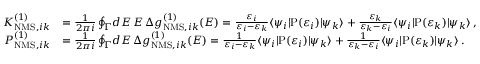Convert formula to latex. <formula><loc_0><loc_0><loc_500><loc_500>\begin{array} { r l } { K _ { N M S , i k } ^ { ( 1 ) } } & { = \frac { 1 } { 2 \pi i } \oint _ { \Gamma } \, d E \, E \, \Delta g _ { N M S , i k } ^ { ( 1 ) } ( E ) = \frac { \varepsilon _ { i } } { \varepsilon _ { i } - \varepsilon _ { k } } \langle \psi _ { i } | P ( \varepsilon _ { i } ) | \psi _ { k } \rangle + \frac { \varepsilon _ { k } } { \varepsilon _ { k } - \varepsilon _ { i } } \langle \psi _ { i } | P ( \varepsilon _ { k } ) | \psi _ { k } \rangle \, , } \\ { P _ { N M S , i k } ^ { ( 1 ) } } & { = \frac { 1 } { 2 \pi i } \oint _ { \Gamma } \, d E \, \Delta g _ { N M S , i k } ^ { ( 1 ) } ( E ) = \frac { 1 } { \varepsilon _ { i } - \varepsilon _ { k } } \langle \psi _ { i } | P ( \varepsilon _ { i } ) | \psi _ { k } \rangle + \frac { 1 } { \varepsilon _ { k } - \varepsilon _ { i } } \langle \psi _ { i } | P ( \varepsilon _ { k } ) | \psi _ { k } \rangle \, . } \end{array}</formula> 